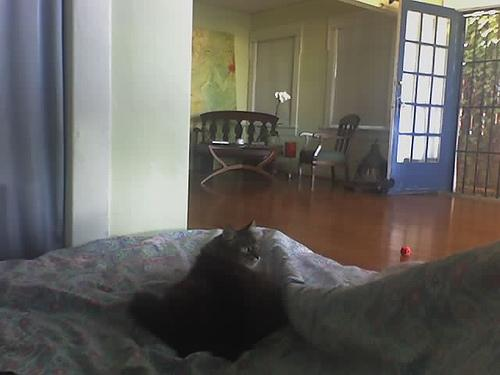The animal is resting on what?

Choices:
A) owner's head
B) chair
C) tub
D) blanket blanket 